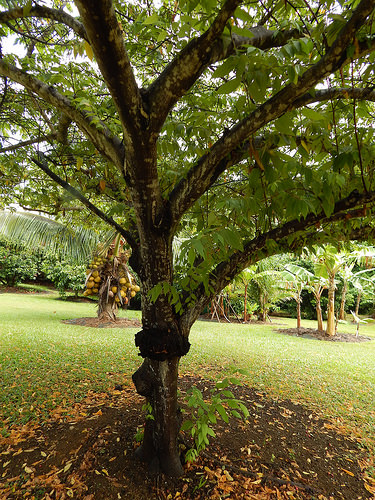<image>
Is there a tree behind the grass? No. The tree is not behind the grass. From this viewpoint, the tree appears to be positioned elsewhere in the scene. 